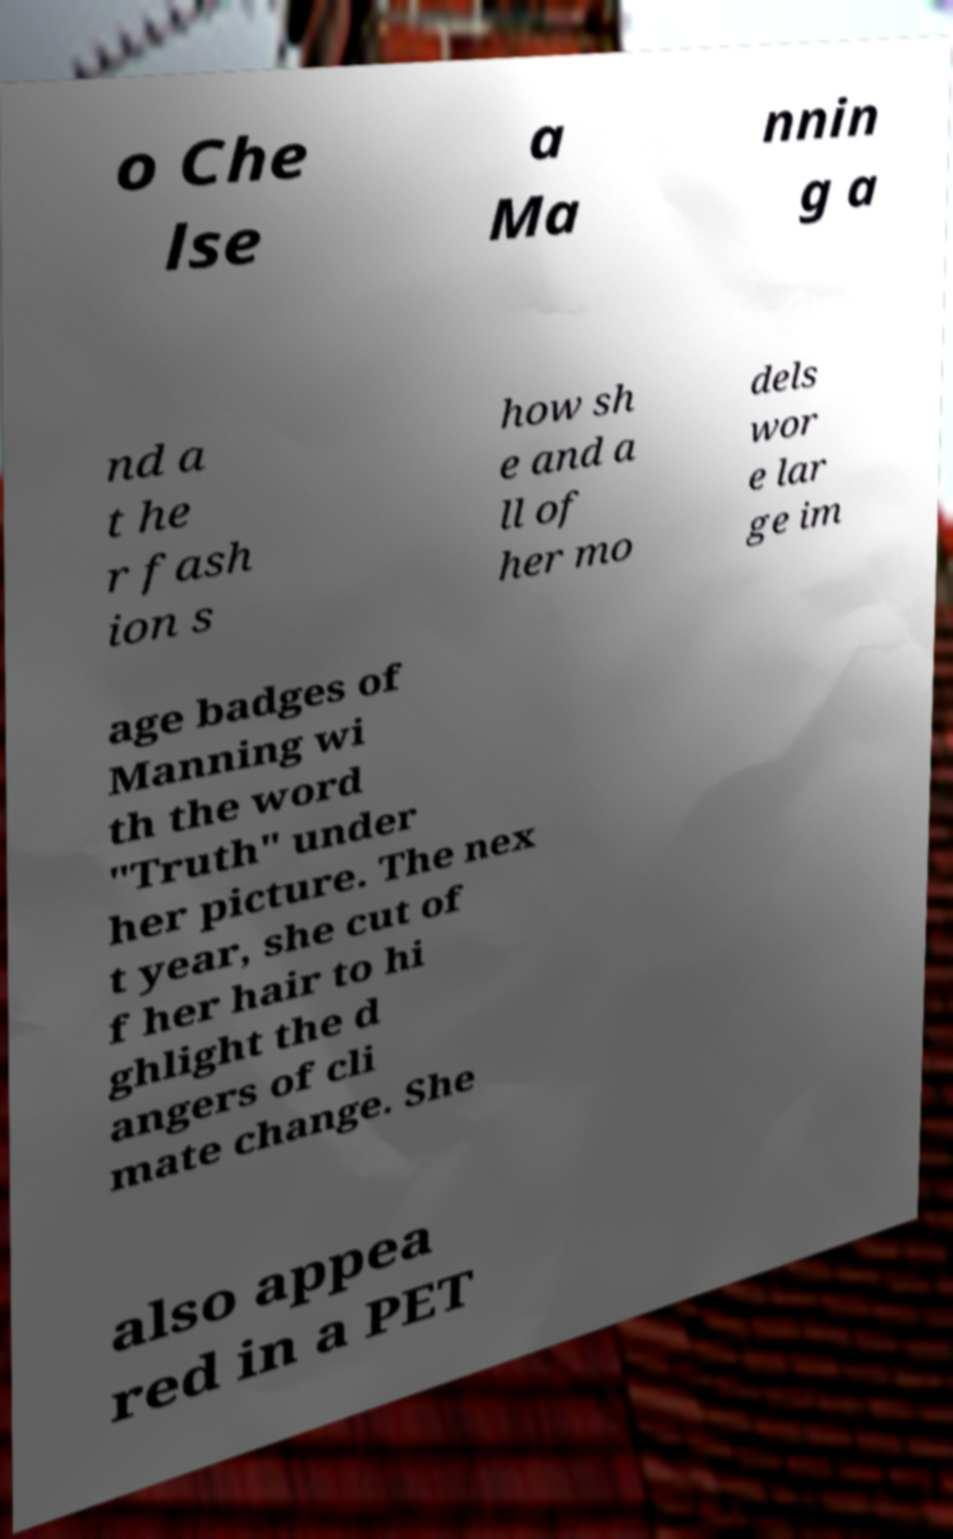Could you assist in decoding the text presented in this image and type it out clearly? o Che lse a Ma nnin g a nd a t he r fash ion s how sh e and a ll of her mo dels wor e lar ge im age badges of Manning wi th the word "Truth" under her picture. The nex t year, she cut of f her hair to hi ghlight the d angers of cli mate change. She also appea red in a PET 